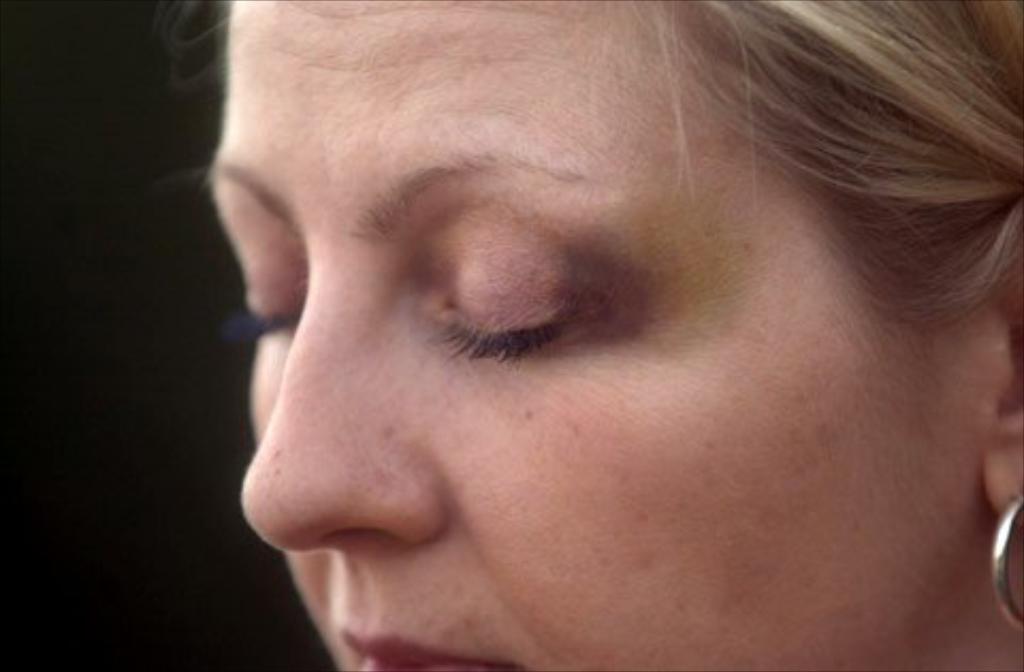Can you describe this image briefly? In this picture we can see a woman. She is wearing earring. 